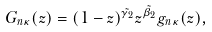Convert formula to latex. <formula><loc_0><loc_0><loc_500><loc_500>G _ { n \kappa } ( z ) = ( 1 - z ) ^ { \tilde { \gamma _ { 2 } } } z ^ { \tilde { \beta _ { 2 } } } g _ { n \kappa } ( z ) ,</formula> 